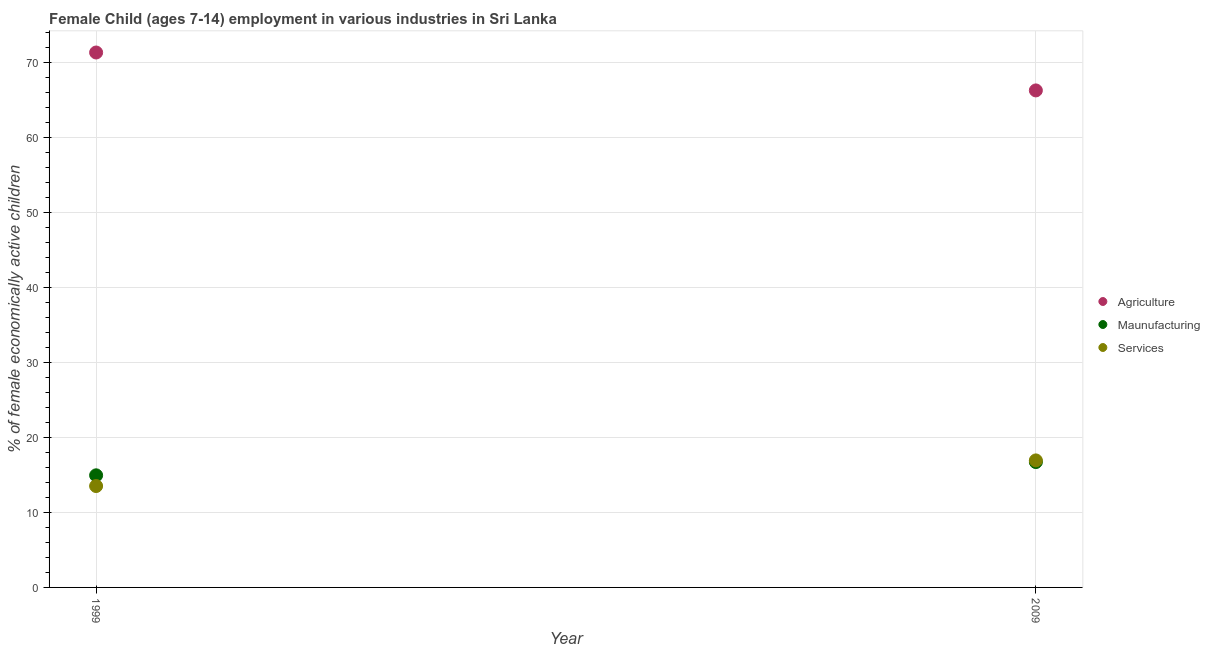How many different coloured dotlines are there?
Provide a succinct answer. 3. What is the percentage of economically active children in agriculture in 2009?
Offer a terse response. 66.32. Across all years, what is the maximum percentage of economically active children in agriculture?
Offer a terse response. 71.38. Across all years, what is the minimum percentage of economically active children in manufacturing?
Your answer should be compact. 14.96. In which year was the percentage of economically active children in agriculture minimum?
Provide a short and direct response. 2009. What is the total percentage of economically active children in services in the graph?
Provide a succinct answer. 30.48. What is the difference between the percentage of economically active children in services in 1999 and that in 2009?
Offer a terse response. -3.42. What is the difference between the percentage of economically active children in manufacturing in 1999 and the percentage of economically active children in services in 2009?
Your response must be concise. -1.99. What is the average percentage of economically active children in manufacturing per year?
Provide a succinct answer. 15.85. In the year 1999, what is the difference between the percentage of economically active children in agriculture and percentage of economically active children in manufacturing?
Make the answer very short. 56.42. What is the ratio of the percentage of economically active children in services in 1999 to that in 2009?
Keep it short and to the point. 0.8. Is it the case that in every year, the sum of the percentage of economically active children in agriculture and percentage of economically active children in manufacturing is greater than the percentage of economically active children in services?
Provide a short and direct response. Yes. Does the percentage of economically active children in manufacturing monotonically increase over the years?
Your answer should be compact. Yes. Is the percentage of economically active children in manufacturing strictly greater than the percentage of economically active children in services over the years?
Offer a terse response. No. How many dotlines are there?
Provide a short and direct response. 3. What is the difference between two consecutive major ticks on the Y-axis?
Give a very brief answer. 10. What is the title of the graph?
Keep it short and to the point. Female Child (ages 7-14) employment in various industries in Sri Lanka. What is the label or title of the X-axis?
Offer a very short reply. Year. What is the label or title of the Y-axis?
Give a very brief answer. % of female economically active children. What is the % of female economically active children in Agriculture in 1999?
Offer a very short reply. 71.38. What is the % of female economically active children of Maunufacturing in 1999?
Offer a very short reply. 14.96. What is the % of female economically active children of Services in 1999?
Offer a terse response. 13.53. What is the % of female economically active children of Agriculture in 2009?
Keep it short and to the point. 66.32. What is the % of female economically active children in Maunufacturing in 2009?
Provide a succinct answer. 16.73. What is the % of female economically active children in Services in 2009?
Your answer should be very brief. 16.95. Across all years, what is the maximum % of female economically active children of Agriculture?
Your answer should be very brief. 71.38. Across all years, what is the maximum % of female economically active children in Maunufacturing?
Your response must be concise. 16.73. Across all years, what is the maximum % of female economically active children of Services?
Make the answer very short. 16.95. Across all years, what is the minimum % of female economically active children in Agriculture?
Ensure brevity in your answer.  66.32. Across all years, what is the minimum % of female economically active children of Maunufacturing?
Give a very brief answer. 14.96. Across all years, what is the minimum % of female economically active children of Services?
Your answer should be very brief. 13.53. What is the total % of female economically active children in Agriculture in the graph?
Your answer should be very brief. 137.7. What is the total % of female economically active children of Maunufacturing in the graph?
Offer a terse response. 31.69. What is the total % of female economically active children of Services in the graph?
Offer a terse response. 30.48. What is the difference between the % of female economically active children in Agriculture in 1999 and that in 2009?
Your response must be concise. 5.06. What is the difference between the % of female economically active children in Maunufacturing in 1999 and that in 2009?
Give a very brief answer. -1.77. What is the difference between the % of female economically active children in Services in 1999 and that in 2009?
Your response must be concise. -3.42. What is the difference between the % of female economically active children in Agriculture in 1999 and the % of female economically active children in Maunufacturing in 2009?
Your response must be concise. 54.65. What is the difference between the % of female economically active children in Agriculture in 1999 and the % of female economically active children in Services in 2009?
Offer a very short reply. 54.43. What is the difference between the % of female economically active children of Maunufacturing in 1999 and the % of female economically active children of Services in 2009?
Your response must be concise. -1.99. What is the average % of female economically active children of Agriculture per year?
Give a very brief answer. 68.85. What is the average % of female economically active children in Maunufacturing per year?
Your answer should be compact. 15.85. What is the average % of female economically active children of Services per year?
Your answer should be very brief. 15.24. In the year 1999, what is the difference between the % of female economically active children of Agriculture and % of female economically active children of Maunufacturing?
Offer a very short reply. 56.42. In the year 1999, what is the difference between the % of female economically active children in Agriculture and % of female economically active children in Services?
Give a very brief answer. 57.85. In the year 1999, what is the difference between the % of female economically active children of Maunufacturing and % of female economically active children of Services?
Offer a very short reply. 1.43. In the year 2009, what is the difference between the % of female economically active children in Agriculture and % of female economically active children in Maunufacturing?
Your answer should be very brief. 49.59. In the year 2009, what is the difference between the % of female economically active children of Agriculture and % of female economically active children of Services?
Your answer should be very brief. 49.37. In the year 2009, what is the difference between the % of female economically active children of Maunufacturing and % of female economically active children of Services?
Keep it short and to the point. -0.22. What is the ratio of the % of female economically active children in Agriculture in 1999 to that in 2009?
Ensure brevity in your answer.  1.08. What is the ratio of the % of female economically active children of Maunufacturing in 1999 to that in 2009?
Your answer should be compact. 0.89. What is the ratio of the % of female economically active children in Services in 1999 to that in 2009?
Your response must be concise. 0.8. What is the difference between the highest and the second highest % of female economically active children of Agriculture?
Your answer should be very brief. 5.06. What is the difference between the highest and the second highest % of female economically active children of Maunufacturing?
Your answer should be very brief. 1.77. What is the difference between the highest and the second highest % of female economically active children of Services?
Give a very brief answer. 3.42. What is the difference between the highest and the lowest % of female economically active children in Agriculture?
Give a very brief answer. 5.06. What is the difference between the highest and the lowest % of female economically active children of Maunufacturing?
Provide a short and direct response. 1.77. What is the difference between the highest and the lowest % of female economically active children in Services?
Provide a short and direct response. 3.42. 